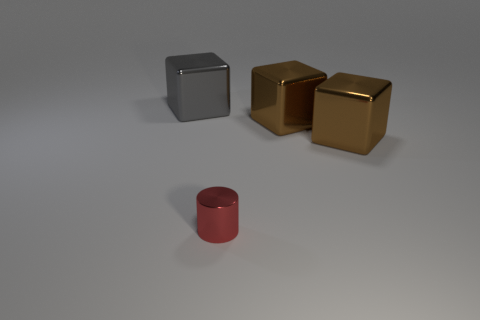Are there any big gray metal objects of the same shape as the red metal object?
Offer a terse response. No. Do the red cylinder and the gray block have the same size?
Your answer should be very brief. No. What is the material of the red cylinder?
Provide a short and direct response. Metal. Does the big shiny object to the left of the small red metallic thing have the same shape as the small red thing?
Your response must be concise. No. What number of things are either red cylinders or big metal things?
Make the answer very short. 4. Are the object that is to the left of the small shiny cylinder and the tiny thing made of the same material?
Make the answer very short. Yes. The red metallic cylinder has what size?
Your response must be concise. Small. What number of spheres are brown objects or small things?
Keep it short and to the point. 0. Are there the same number of gray cubes behind the red thing and brown metallic things right of the big gray shiny block?
Your response must be concise. No. Are there any tiny red shiny objects behind the small red object?
Offer a very short reply. No. 